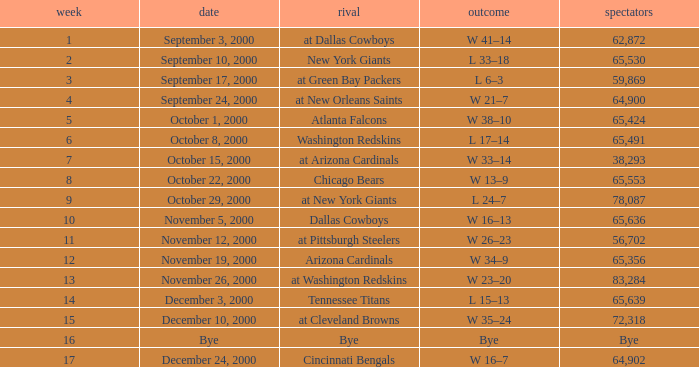What was the attendance when the Cincinnati Bengals were the opponents? 64902.0. 